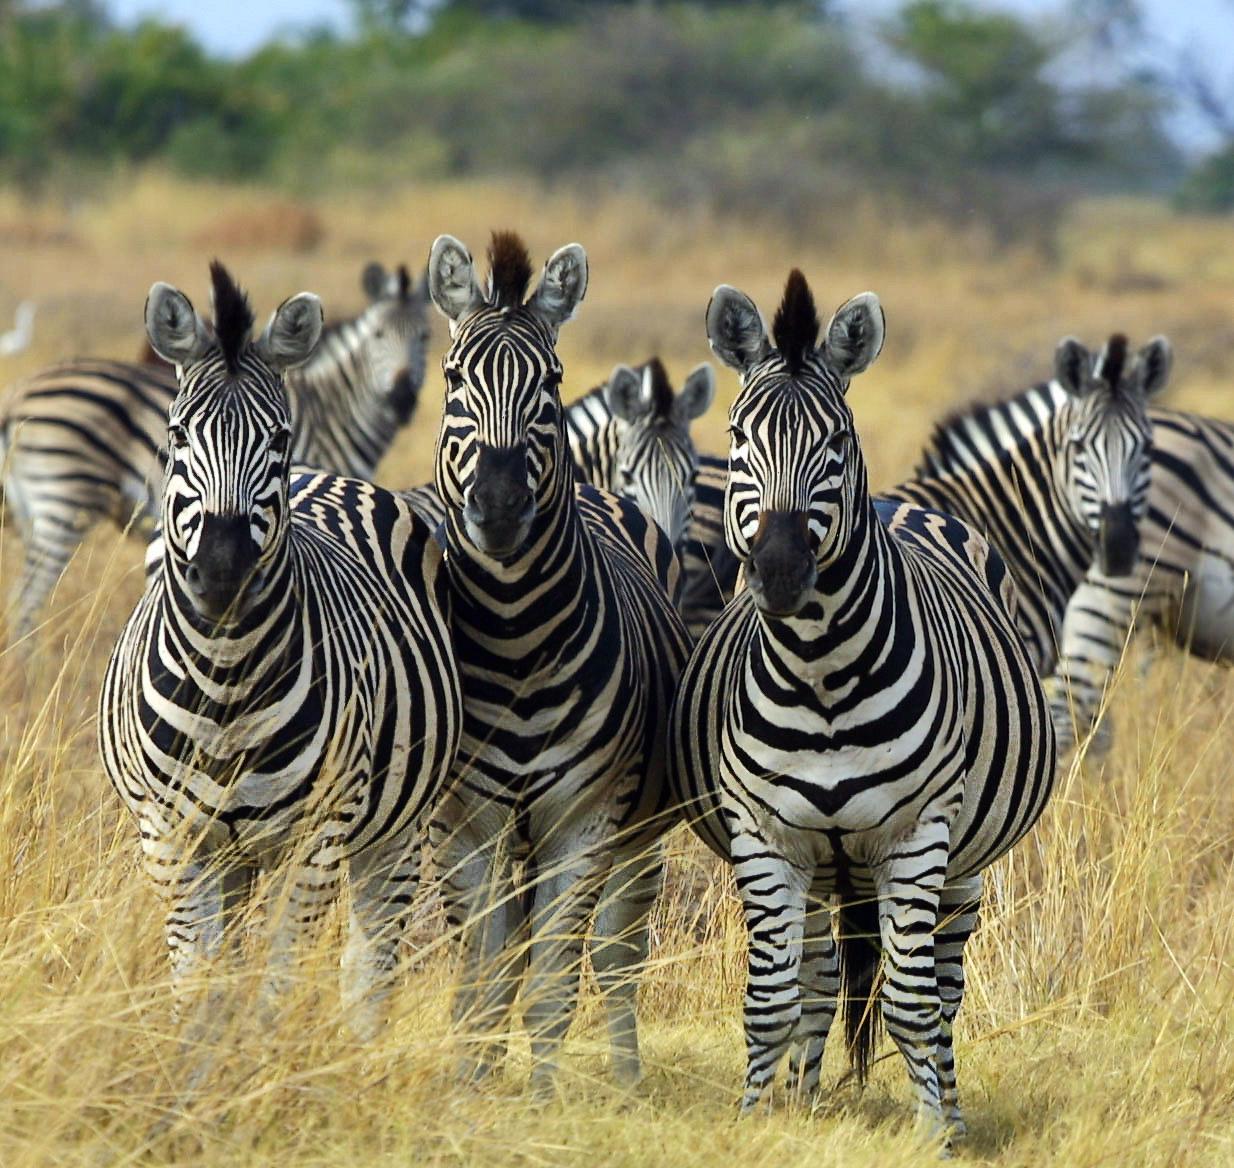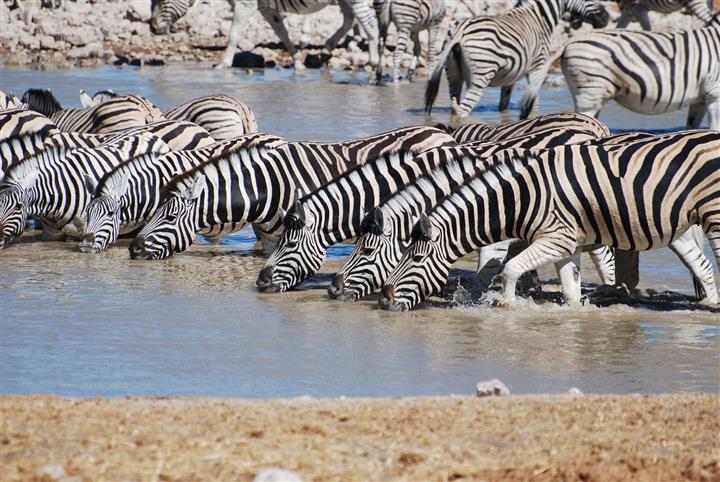The first image is the image on the left, the second image is the image on the right. Considering the images on both sides, is "There are zebras drinking water." valid? Answer yes or no. Yes. The first image is the image on the left, the second image is the image on the right. For the images shown, is this caption "An image shows a row of zebras with the adult zebras bending their necks to the water as they stand in water." true? Answer yes or no. Yes. 